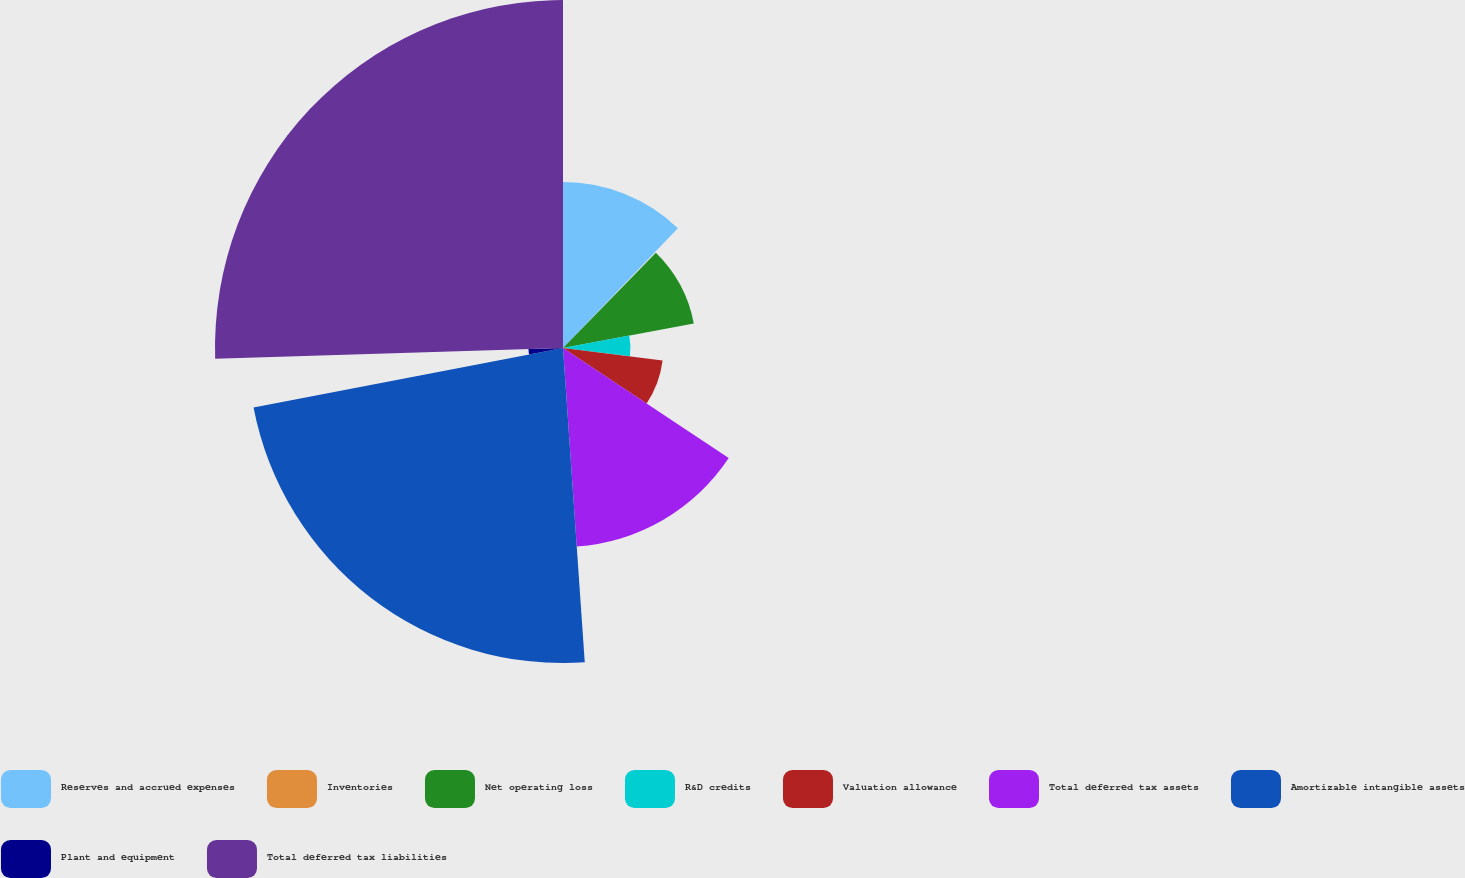<chart> <loc_0><loc_0><loc_500><loc_500><pie_chart><fcel>Reserves and accrued expenses<fcel>Inventories<fcel>Net operating loss<fcel>R&D credits<fcel>Valuation allowance<fcel>Total deferred tax assets<fcel>Amortizable intangible assets<fcel>Plant and equipment<fcel>Total deferred tax liabilities<nl><fcel>12.16%<fcel>0.13%<fcel>9.75%<fcel>4.94%<fcel>7.35%<fcel>14.57%<fcel>23.08%<fcel>2.53%<fcel>25.49%<nl></chart> 